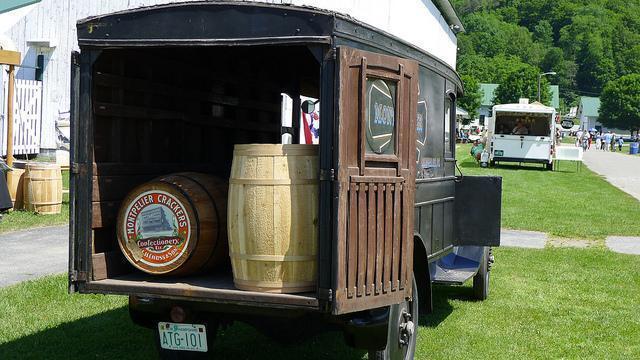How many trucks are there?
Give a very brief answer. 2. 